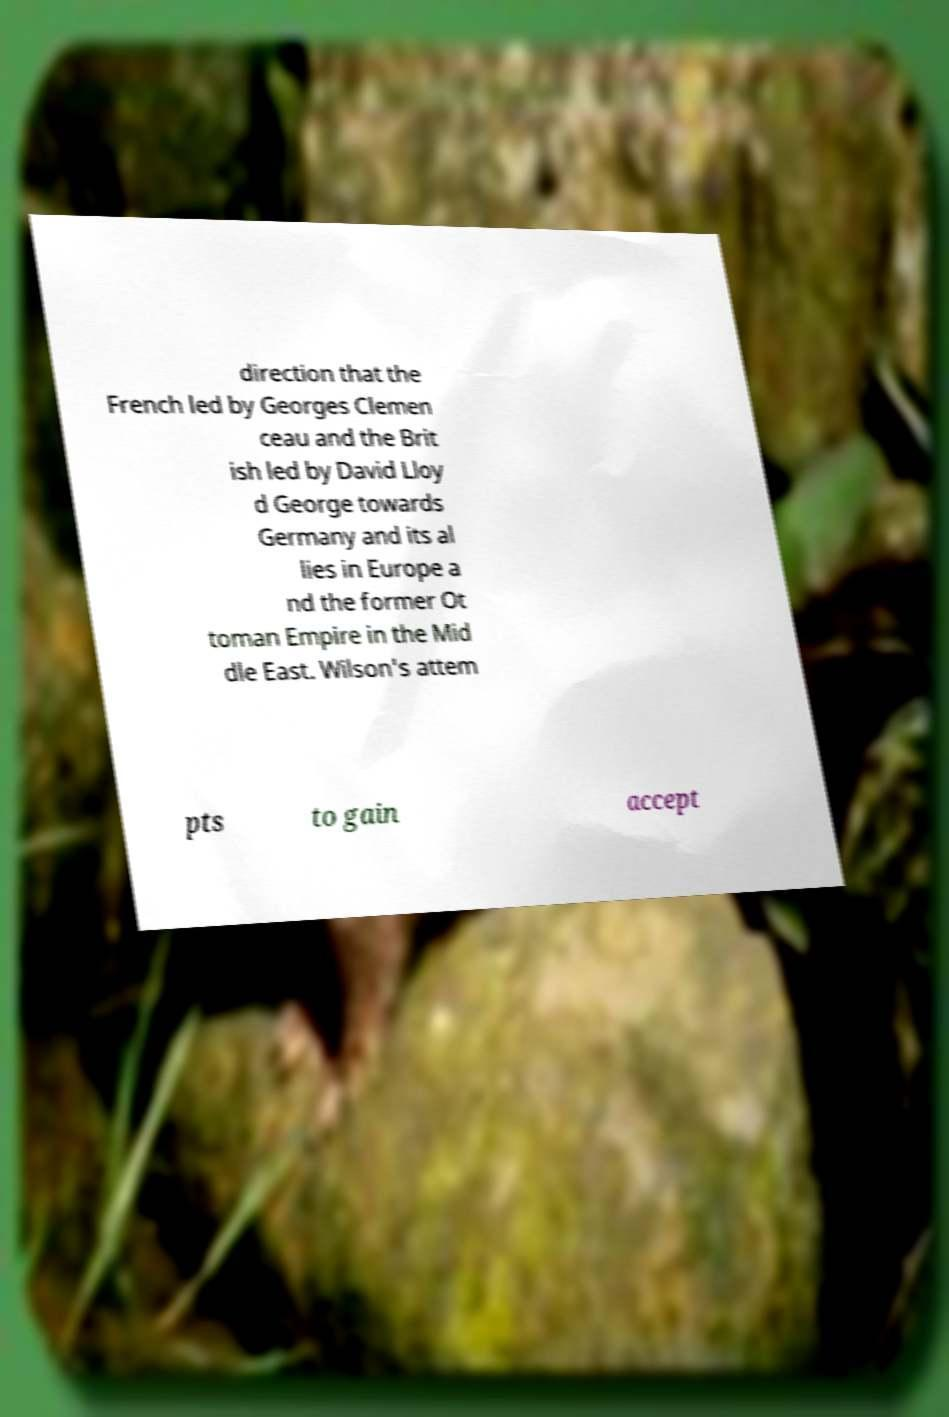There's text embedded in this image that I need extracted. Can you transcribe it verbatim? direction that the French led by Georges Clemen ceau and the Brit ish led by David Lloy d George towards Germany and its al lies in Europe a nd the former Ot toman Empire in the Mid dle East. Wilson's attem pts to gain accept 